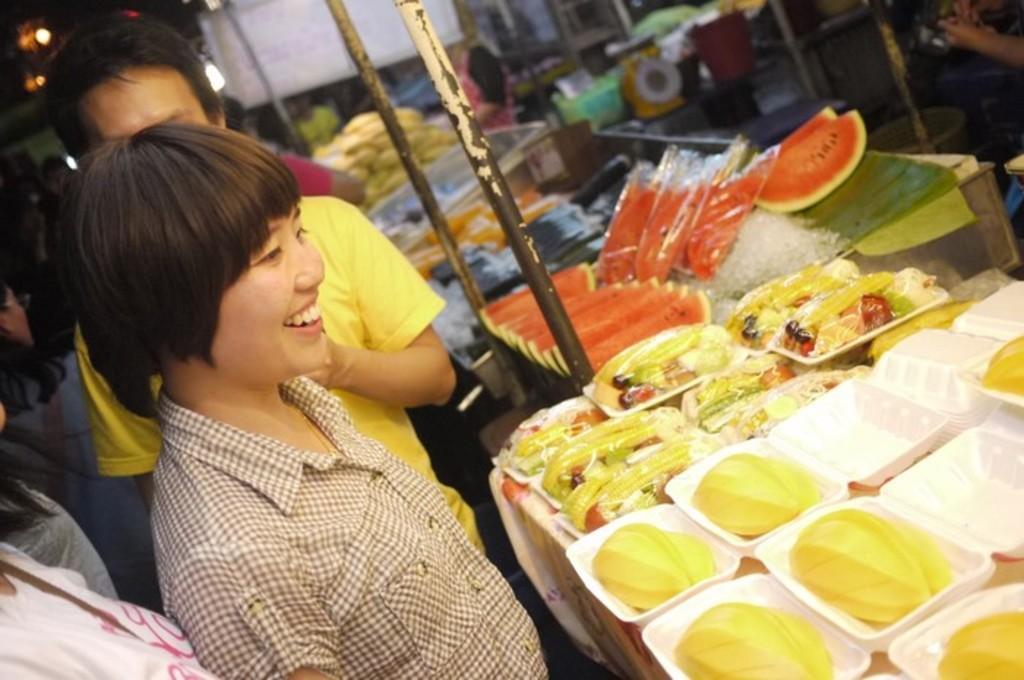Please provide a concise description of this image. This picture seems to be clicked inside. On the right we can see there are many number of food items and we can see the fruits. On the left we can see the group of persons standing and there are some metal rods. In the background there is a wall and we can see the lights and some other objects. 